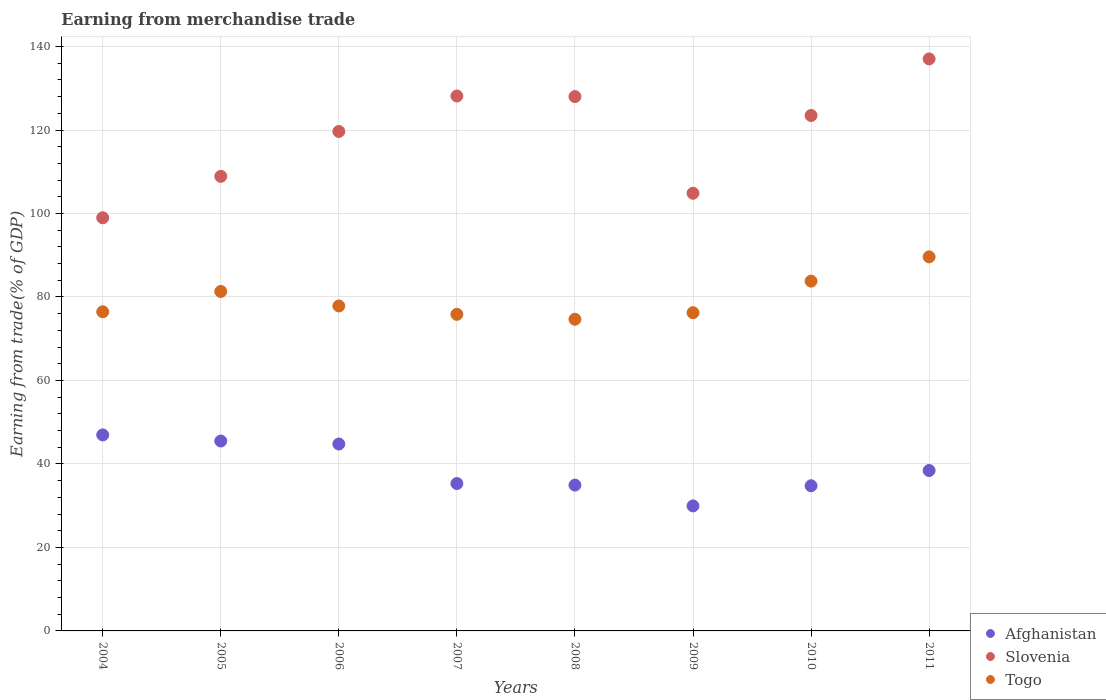What is the earnings from trade in Togo in 2008?
Keep it short and to the point. 74.67. Across all years, what is the maximum earnings from trade in Togo?
Your answer should be very brief. 89.62. Across all years, what is the minimum earnings from trade in Togo?
Make the answer very short. 74.67. What is the total earnings from trade in Slovenia in the graph?
Ensure brevity in your answer.  949.1. What is the difference between the earnings from trade in Slovenia in 2008 and that in 2010?
Offer a very short reply. 4.53. What is the difference between the earnings from trade in Togo in 2008 and the earnings from trade in Afghanistan in 2010?
Offer a very short reply. 39.89. What is the average earnings from trade in Togo per year?
Ensure brevity in your answer.  79.48. In the year 2009, what is the difference between the earnings from trade in Togo and earnings from trade in Afghanistan?
Offer a terse response. 46.29. What is the ratio of the earnings from trade in Togo in 2004 to that in 2006?
Offer a very short reply. 0.98. Is the earnings from trade in Togo in 2007 less than that in 2008?
Make the answer very short. No. Is the difference between the earnings from trade in Togo in 2004 and 2006 greater than the difference between the earnings from trade in Afghanistan in 2004 and 2006?
Offer a terse response. No. What is the difference between the highest and the second highest earnings from trade in Togo?
Give a very brief answer. 5.82. What is the difference between the highest and the lowest earnings from trade in Slovenia?
Keep it short and to the point. 38.05. In how many years, is the earnings from trade in Afghanistan greater than the average earnings from trade in Afghanistan taken over all years?
Ensure brevity in your answer.  3. Is it the case that in every year, the sum of the earnings from trade in Slovenia and earnings from trade in Afghanistan  is greater than the earnings from trade in Togo?
Offer a very short reply. Yes. Is the earnings from trade in Togo strictly less than the earnings from trade in Slovenia over the years?
Keep it short and to the point. Yes. How many years are there in the graph?
Provide a short and direct response. 8. Are the values on the major ticks of Y-axis written in scientific E-notation?
Keep it short and to the point. No. Does the graph contain grids?
Your answer should be very brief. Yes. How are the legend labels stacked?
Your answer should be very brief. Vertical. What is the title of the graph?
Ensure brevity in your answer.  Earning from merchandise trade. Does "Guam" appear as one of the legend labels in the graph?
Give a very brief answer. No. What is the label or title of the X-axis?
Make the answer very short. Years. What is the label or title of the Y-axis?
Provide a short and direct response. Earning from trade(% of GDP). What is the Earning from trade(% of GDP) of Afghanistan in 2004?
Offer a terse response. 46.96. What is the Earning from trade(% of GDP) of Slovenia in 2004?
Ensure brevity in your answer.  98.98. What is the Earning from trade(% of GDP) in Togo in 2004?
Provide a short and direct response. 76.46. What is the Earning from trade(% of GDP) of Afghanistan in 2005?
Your answer should be very brief. 45.49. What is the Earning from trade(% of GDP) of Slovenia in 2005?
Your answer should be compact. 108.91. What is the Earning from trade(% of GDP) in Togo in 2005?
Provide a succinct answer. 81.33. What is the Earning from trade(% of GDP) in Afghanistan in 2006?
Offer a very short reply. 44.78. What is the Earning from trade(% of GDP) in Slovenia in 2006?
Your answer should be compact. 119.66. What is the Earning from trade(% of GDP) in Togo in 2006?
Make the answer very short. 77.85. What is the Earning from trade(% of GDP) in Afghanistan in 2007?
Give a very brief answer. 35.31. What is the Earning from trade(% of GDP) of Slovenia in 2007?
Offer a terse response. 128.15. What is the Earning from trade(% of GDP) in Togo in 2007?
Ensure brevity in your answer.  75.85. What is the Earning from trade(% of GDP) of Afghanistan in 2008?
Your response must be concise. 34.93. What is the Earning from trade(% of GDP) of Slovenia in 2008?
Provide a succinct answer. 128.01. What is the Earning from trade(% of GDP) in Togo in 2008?
Offer a terse response. 74.67. What is the Earning from trade(% of GDP) of Afghanistan in 2009?
Provide a succinct answer. 29.95. What is the Earning from trade(% of GDP) of Slovenia in 2009?
Your answer should be compact. 104.86. What is the Earning from trade(% of GDP) of Togo in 2009?
Keep it short and to the point. 76.24. What is the Earning from trade(% of GDP) of Afghanistan in 2010?
Provide a succinct answer. 34.78. What is the Earning from trade(% of GDP) in Slovenia in 2010?
Provide a succinct answer. 123.49. What is the Earning from trade(% of GDP) of Togo in 2010?
Keep it short and to the point. 83.8. What is the Earning from trade(% of GDP) of Afghanistan in 2011?
Your response must be concise. 38.43. What is the Earning from trade(% of GDP) of Slovenia in 2011?
Your response must be concise. 137.04. What is the Earning from trade(% of GDP) of Togo in 2011?
Ensure brevity in your answer.  89.62. Across all years, what is the maximum Earning from trade(% of GDP) in Afghanistan?
Offer a very short reply. 46.96. Across all years, what is the maximum Earning from trade(% of GDP) of Slovenia?
Your answer should be compact. 137.04. Across all years, what is the maximum Earning from trade(% of GDP) of Togo?
Your answer should be compact. 89.62. Across all years, what is the minimum Earning from trade(% of GDP) in Afghanistan?
Make the answer very short. 29.95. Across all years, what is the minimum Earning from trade(% of GDP) of Slovenia?
Provide a succinct answer. 98.98. Across all years, what is the minimum Earning from trade(% of GDP) of Togo?
Your answer should be very brief. 74.67. What is the total Earning from trade(% of GDP) in Afghanistan in the graph?
Keep it short and to the point. 310.64. What is the total Earning from trade(% of GDP) in Slovenia in the graph?
Provide a short and direct response. 949.1. What is the total Earning from trade(% of GDP) in Togo in the graph?
Your answer should be compact. 635.82. What is the difference between the Earning from trade(% of GDP) of Afghanistan in 2004 and that in 2005?
Make the answer very short. 1.47. What is the difference between the Earning from trade(% of GDP) in Slovenia in 2004 and that in 2005?
Your answer should be compact. -9.92. What is the difference between the Earning from trade(% of GDP) of Togo in 2004 and that in 2005?
Provide a short and direct response. -4.88. What is the difference between the Earning from trade(% of GDP) in Afghanistan in 2004 and that in 2006?
Keep it short and to the point. 2.18. What is the difference between the Earning from trade(% of GDP) of Slovenia in 2004 and that in 2006?
Ensure brevity in your answer.  -20.68. What is the difference between the Earning from trade(% of GDP) of Togo in 2004 and that in 2006?
Keep it short and to the point. -1.4. What is the difference between the Earning from trade(% of GDP) of Afghanistan in 2004 and that in 2007?
Offer a very short reply. 11.65. What is the difference between the Earning from trade(% of GDP) in Slovenia in 2004 and that in 2007?
Your response must be concise. -29.17. What is the difference between the Earning from trade(% of GDP) in Togo in 2004 and that in 2007?
Give a very brief answer. 0.61. What is the difference between the Earning from trade(% of GDP) in Afghanistan in 2004 and that in 2008?
Your response must be concise. 12.03. What is the difference between the Earning from trade(% of GDP) of Slovenia in 2004 and that in 2008?
Offer a terse response. -29.03. What is the difference between the Earning from trade(% of GDP) of Togo in 2004 and that in 2008?
Give a very brief answer. 1.79. What is the difference between the Earning from trade(% of GDP) in Afghanistan in 2004 and that in 2009?
Keep it short and to the point. 17.01. What is the difference between the Earning from trade(% of GDP) in Slovenia in 2004 and that in 2009?
Your answer should be very brief. -5.87. What is the difference between the Earning from trade(% of GDP) in Togo in 2004 and that in 2009?
Your answer should be compact. 0.21. What is the difference between the Earning from trade(% of GDP) in Afghanistan in 2004 and that in 2010?
Your answer should be compact. 12.18. What is the difference between the Earning from trade(% of GDP) of Slovenia in 2004 and that in 2010?
Ensure brevity in your answer.  -24.5. What is the difference between the Earning from trade(% of GDP) of Togo in 2004 and that in 2010?
Make the answer very short. -7.34. What is the difference between the Earning from trade(% of GDP) in Afghanistan in 2004 and that in 2011?
Keep it short and to the point. 8.53. What is the difference between the Earning from trade(% of GDP) in Slovenia in 2004 and that in 2011?
Your answer should be compact. -38.05. What is the difference between the Earning from trade(% of GDP) of Togo in 2004 and that in 2011?
Offer a terse response. -13.16. What is the difference between the Earning from trade(% of GDP) of Afghanistan in 2005 and that in 2006?
Provide a short and direct response. 0.72. What is the difference between the Earning from trade(% of GDP) in Slovenia in 2005 and that in 2006?
Provide a succinct answer. -10.75. What is the difference between the Earning from trade(% of GDP) of Togo in 2005 and that in 2006?
Make the answer very short. 3.48. What is the difference between the Earning from trade(% of GDP) in Afghanistan in 2005 and that in 2007?
Give a very brief answer. 10.18. What is the difference between the Earning from trade(% of GDP) of Slovenia in 2005 and that in 2007?
Provide a succinct answer. -19.25. What is the difference between the Earning from trade(% of GDP) in Togo in 2005 and that in 2007?
Make the answer very short. 5.49. What is the difference between the Earning from trade(% of GDP) of Afghanistan in 2005 and that in 2008?
Your answer should be compact. 10.56. What is the difference between the Earning from trade(% of GDP) of Slovenia in 2005 and that in 2008?
Offer a very short reply. -19.11. What is the difference between the Earning from trade(% of GDP) in Togo in 2005 and that in 2008?
Your answer should be very brief. 6.67. What is the difference between the Earning from trade(% of GDP) in Afghanistan in 2005 and that in 2009?
Your answer should be very brief. 15.54. What is the difference between the Earning from trade(% of GDP) in Slovenia in 2005 and that in 2009?
Offer a very short reply. 4.05. What is the difference between the Earning from trade(% of GDP) of Togo in 2005 and that in 2009?
Offer a terse response. 5.09. What is the difference between the Earning from trade(% of GDP) of Afghanistan in 2005 and that in 2010?
Your answer should be compact. 10.71. What is the difference between the Earning from trade(% of GDP) in Slovenia in 2005 and that in 2010?
Give a very brief answer. -14.58. What is the difference between the Earning from trade(% of GDP) of Togo in 2005 and that in 2010?
Ensure brevity in your answer.  -2.47. What is the difference between the Earning from trade(% of GDP) in Afghanistan in 2005 and that in 2011?
Make the answer very short. 7.06. What is the difference between the Earning from trade(% of GDP) of Slovenia in 2005 and that in 2011?
Offer a very short reply. -28.13. What is the difference between the Earning from trade(% of GDP) of Togo in 2005 and that in 2011?
Ensure brevity in your answer.  -8.28. What is the difference between the Earning from trade(% of GDP) in Afghanistan in 2006 and that in 2007?
Make the answer very short. 9.47. What is the difference between the Earning from trade(% of GDP) of Slovenia in 2006 and that in 2007?
Your answer should be compact. -8.49. What is the difference between the Earning from trade(% of GDP) in Togo in 2006 and that in 2007?
Offer a terse response. 2.01. What is the difference between the Earning from trade(% of GDP) of Afghanistan in 2006 and that in 2008?
Your answer should be very brief. 9.84. What is the difference between the Earning from trade(% of GDP) of Slovenia in 2006 and that in 2008?
Offer a terse response. -8.35. What is the difference between the Earning from trade(% of GDP) of Togo in 2006 and that in 2008?
Ensure brevity in your answer.  3.19. What is the difference between the Earning from trade(% of GDP) in Afghanistan in 2006 and that in 2009?
Keep it short and to the point. 14.83. What is the difference between the Earning from trade(% of GDP) of Slovenia in 2006 and that in 2009?
Offer a terse response. 14.81. What is the difference between the Earning from trade(% of GDP) in Togo in 2006 and that in 2009?
Your answer should be very brief. 1.61. What is the difference between the Earning from trade(% of GDP) of Afghanistan in 2006 and that in 2010?
Your answer should be compact. 10. What is the difference between the Earning from trade(% of GDP) of Slovenia in 2006 and that in 2010?
Ensure brevity in your answer.  -3.83. What is the difference between the Earning from trade(% of GDP) of Togo in 2006 and that in 2010?
Offer a terse response. -5.94. What is the difference between the Earning from trade(% of GDP) in Afghanistan in 2006 and that in 2011?
Offer a terse response. 6.35. What is the difference between the Earning from trade(% of GDP) of Slovenia in 2006 and that in 2011?
Your answer should be very brief. -17.38. What is the difference between the Earning from trade(% of GDP) of Togo in 2006 and that in 2011?
Offer a terse response. -11.76. What is the difference between the Earning from trade(% of GDP) in Afghanistan in 2007 and that in 2008?
Keep it short and to the point. 0.38. What is the difference between the Earning from trade(% of GDP) of Slovenia in 2007 and that in 2008?
Your response must be concise. 0.14. What is the difference between the Earning from trade(% of GDP) of Togo in 2007 and that in 2008?
Your response must be concise. 1.18. What is the difference between the Earning from trade(% of GDP) of Afghanistan in 2007 and that in 2009?
Make the answer very short. 5.36. What is the difference between the Earning from trade(% of GDP) of Slovenia in 2007 and that in 2009?
Keep it short and to the point. 23.3. What is the difference between the Earning from trade(% of GDP) in Togo in 2007 and that in 2009?
Offer a terse response. -0.39. What is the difference between the Earning from trade(% of GDP) in Afghanistan in 2007 and that in 2010?
Provide a short and direct response. 0.53. What is the difference between the Earning from trade(% of GDP) in Slovenia in 2007 and that in 2010?
Make the answer very short. 4.67. What is the difference between the Earning from trade(% of GDP) of Togo in 2007 and that in 2010?
Keep it short and to the point. -7.95. What is the difference between the Earning from trade(% of GDP) in Afghanistan in 2007 and that in 2011?
Your answer should be very brief. -3.12. What is the difference between the Earning from trade(% of GDP) of Slovenia in 2007 and that in 2011?
Your answer should be very brief. -8.88. What is the difference between the Earning from trade(% of GDP) of Togo in 2007 and that in 2011?
Ensure brevity in your answer.  -13.77. What is the difference between the Earning from trade(% of GDP) of Afghanistan in 2008 and that in 2009?
Your answer should be very brief. 4.98. What is the difference between the Earning from trade(% of GDP) of Slovenia in 2008 and that in 2009?
Your answer should be compact. 23.16. What is the difference between the Earning from trade(% of GDP) of Togo in 2008 and that in 2009?
Make the answer very short. -1.58. What is the difference between the Earning from trade(% of GDP) of Afghanistan in 2008 and that in 2010?
Provide a short and direct response. 0.15. What is the difference between the Earning from trade(% of GDP) of Slovenia in 2008 and that in 2010?
Give a very brief answer. 4.53. What is the difference between the Earning from trade(% of GDP) in Togo in 2008 and that in 2010?
Offer a very short reply. -9.13. What is the difference between the Earning from trade(% of GDP) of Afghanistan in 2008 and that in 2011?
Make the answer very short. -3.5. What is the difference between the Earning from trade(% of GDP) of Slovenia in 2008 and that in 2011?
Offer a very short reply. -9.02. What is the difference between the Earning from trade(% of GDP) of Togo in 2008 and that in 2011?
Provide a succinct answer. -14.95. What is the difference between the Earning from trade(% of GDP) in Afghanistan in 2009 and that in 2010?
Provide a succinct answer. -4.83. What is the difference between the Earning from trade(% of GDP) of Slovenia in 2009 and that in 2010?
Offer a very short reply. -18.63. What is the difference between the Earning from trade(% of GDP) in Togo in 2009 and that in 2010?
Provide a short and direct response. -7.56. What is the difference between the Earning from trade(% of GDP) in Afghanistan in 2009 and that in 2011?
Give a very brief answer. -8.48. What is the difference between the Earning from trade(% of GDP) in Slovenia in 2009 and that in 2011?
Your response must be concise. -32.18. What is the difference between the Earning from trade(% of GDP) in Togo in 2009 and that in 2011?
Provide a short and direct response. -13.37. What is the difference between the Earning from trade(% of GDP) of Afghanistan in 2010 and that in 2011?
Give a very brief answer. -3.65. What is the difference between the Earning from trade(% of GDP) in Slovenia in 2010 and that in 2011?
Your answer should be compact. -13.55. What is the difference between the Earning from trade(% of GDP) of Togo in 2010 and that in 2011?
Offer a very short reply. -5.82. What is the difference between the Earning from trade(% of GDP) of Afghanistan in 2004 and the Earning from trade(% of GDP) of Slovenia in 2005?
Your answer should be compact. -61.95. What is the difference between the Earning from trade(% of GDP) in Afghanistan in 2004 and the Earning from trade(% of GDP) in Togo in 2005?
Keep it short and to the point. -34.38. What is the difference between the Earning from trade(% of GDP) of Slovenia in 2004 and the Earning from trade(% of GDP) of Togo in 2005?
Offer a terse response. 17.65. What is the difference between the Earning from trade(% of GDP) of Afghanistan in 2004 and the Earning from trade(% of GDP) of Slovenia in 2006?
Your response must be concise. -72.7. What is the difference between the Earning from trade(% of GDP) of Afghanistan in 2004 and the Earning from trade(% of GDP) of Togo in 2006?
Your answer should be compact. -30.9. What is the difference between the Earning from trade(% of GDP) in Slovenia in 2004 and the Earning from trade(% of GDP) in Togo in 2006?
Your answer should be very brief. 21.13. What is the difference between the Earning from trade(% of GDP) of Afghanistan in 2004 and the Earning from trade(% of GDP) of Slovenia in 2007?
Give a very brief answer. -81.19. What is the difference between the Earning from trade(% of GDP) of Afghanistan in 2004 and the Earning from trade(% of GDP) of Togo in 2007?
Your response must be concise. -28.89. What is the difference between the Earning from trade(% of GDP) of Slovenia in 2004 and the Earning from trade(% of GDP) of Togo in 2007?
Offer a terse response. 23.14. What is the difference between the Earning from trade(% of GDP) in Afghanistan in 2004 and the Earning from trade(% of GDP) in Slovenia in 2008?
Provide a short and direct response. -81.05. What is the difference between the Earning from trade(% of GDP) in Afghanistan in 2004 and the Earning from trade(% of GDP) in Togo in 2008?
Your response must be concise. -27.71. What is the difference between the Earning from trade(% of GDP) of Slovenia in 2004 and the Earning from trade(% of GDP) of Togo in 2008?
Provide a succinct answer. 24.32. What is the difference between the Earning from trade(% of GDP) in Afghanistan in 2004 and the Earning from trade(% of GDP) in Slovenia in 2009?
Offer a terse response. -57.9. What is the difference between the Earning from trade(% of GDP) in Afghanistan in 2004 and the Earning from trade(% of GDP) in Togo in 2009?
Provide a short and direct response. -29.28. What is the difference between the Earning from trade(% of GDP) in Slovenia in 2004 and the Earning from trade(% of GDP) in Togo in 2009?
Provide a succinct answer. 22.74. What is the difference between the Earning from trade(% of GDP) in Afghanistan in 2004 and the Earning from trade(% of GDP) in Slovenia in 2010?
Give a very brief answer. -76.53. What is the difference between the Earning from trade(% of GDP) of Afghanistan in 2004 and the Earning from trade(% of GDP) of Togo in 2010?
Give a very brief answer. -36.84. What is the difference between the Earning from trade(% of GDP) of Slovenia in 2004 and the Earning from trade(% of GDP) of Togo in 2010?
Give a very brief answer. 15.18. What is the difference between the Earning from trade(% of GDP) of Afghanistan in 2004 and the Earning from trade(% of GDP) of Slovenia in 2011?
Offer a terse response. -90.08. What is the difference between the Earning from trade(% of GDP) of Afghanistan in 2004 and the Earning from trade(% of GDP) of Togo in 2011?
Your answer should be compact. -42.66. What is the difference between the Earning from trade(% of GDP) of Slovenia in 2004 and the Earning from trade(% of GDP) of Togo in 2011?
Make the answer very short. 9.37. What is the difference between the Earning from trade(% of GDP) in Afghanistan in 2005 and the Earning from trade(% of GDP) in Slovenia in 2006?
Your answer should be compact. -74.17. What is the difference between the Earning from trade(% of GDP) of Afghanistan in 2005 and the Earning from trade(% of GDP) of Togo in 2006?
Make the answer very short. -32.36. What is the difference between the Earning from trade(% of GDP) in Slovenia in 2005 and the Earning from trade(% of GDP) in Togo in 2006?
Offer a terse response. 31.05. What is the difference between the Earning from trade(% of GDP) in Afghanistan in 2005 and the Earning from trade(% of GDP) in Slovenia in 2007?
Your answer should be very brief. -82.66. What is the difference between the Earning from trade(% of GDP) in Afghanistan in 2005 and the Earning from trade(% of GDP) in Togo in 2007?
Provide a succinct answer. -30.36. What is the difference between the Earning from trade(% of GDP) of Slovenia in 2005 and the Earning from trade(% of GDP) of Togo in 2007?
Make the answer very short. 33.06. What is the difference between the Earning from trade(% of GDP) in Afghanistan in 2005 and the Earning from trade(% of GDP) in Slovenia in 2008?
Your response must be concise. -82.52. What is the difference between the Earning from trade(% of GDP) in Afghanistan in 2005 and the Earning from trade(% of GDP) in Togo in 2008?
Provide a succinct answer. -29.17. What is the difference between the Earning from trade(% of GDP) of Slovenia in 2005 and the Earning from trade(% of GDP) of Togo in 2008?
Offer a terse response. 34.24. What is the difference between the Earning from trade(% of GDP) of Afghanistan in 2005 and the Earning from trade(% of GDP) of Slovenia in 2009?
Provide a short and direct response. -59.36. What is the difference between the Earning from trade(% of GDP) of Afghanistan in 2005 and the Earning from trade(% of GDP) of Togo in 2009?
Your answer should be compact. -30.75. What is the difference between the Earning from trade(% of GDP) in Slovenia in 2005 and the Earning from trade(% of GDP) in Togo in 2009?
Your response must be concise. 32.66. What is the difference between the Earning from trade(% of GDP) of Afghanistan in 2005 and the Earning from trade(% of GDP) of Slovenia in 2010?
Provide a succinct answer. -77.99. What is the difference between the Earning from trade(% of GDP) in Afghanistan in 2005 and the Earning from trade(% of GDP) in Togo in 2010?
Your response must be concise. -38.31. What is the difference between the Earning from trade(% of GDP) in Slovenia in 2005 and the Earning from trade(% of GDP) in Togo in 2010?
Make the answer very short. 25.11. What is the difference between the Earning from trade(% of GDP) of Afghanistan in 2005 and the Earning from trade(% of GDP) of Slovenia in 2011?
Your answer should be very brief. -91.54. What is the difference between the Earning from trade(% of GDP) of Afghanistan in 2005 and the Earning from trade(% of GDP) of Togo in 2011?
Your response must be concise. -44.12. What is the difference between the Earning from trade(% of GDP) of Slovenia in 2005 and the Earning from trade(% of GDP) of Togo in 2011?
Offer a very short reply. 19.29. What is the difference between the Earning from trade(% of GDP) in Afghanistan in 2006 and the Earning from trade(% of GDP) in Slovenia in 2007?
Keep it short and to the point. -83.38. What is the difference between the Earning from trade(% of GDP) in Afghanistan in 2006 and the Earning from trade(% of GDP) in Togo in 2007?
Keep it short and to the point. -31.07. What is the difference between the Earning from trade(% of GDP) in Slovenia in 2006 and the Earning from trade(% of GDP) in Togo in 2007?
Ensure brevity in your answer.  43.81. What is the difference between the Earning from trade(% of GDP) of Afghanistan in 2006 and the Earning from trade(% of GDP) of Slovenia in 2008?
Your answer should be very brief. -83.24. What is the difference between the Earning from trade(% of GDP) of Afghanistan in 2006 and the Earning from trade(% of GDP) of Togo in 2008?
Offer a terse response. -29.89. What is the difference between the Earning from trade(% of GDP) in Slovenia in 2006 and the Earning from trade(% of GDP) in Togo in 2008?
Make the answer very short. 44.99. What is the difference between the Earning from trade(% of GDP) of Afghanistan in 2006 and the Earning from trade(% of GDP) of Slovenia in 2009?
Ensure brevity in your answer.  -60.08. What is the difference between the Earning from trade(% of GDP) of Afghanistan in 2006 and the Earning from trade(% of GDP) of Togo in 2009?
Your response must be concise. -31.47. What is the difference between the Earning from trade(% of GDP) of Slovenia in 2006 and the Earning from trade(% of GDP) of Togo in 2009?
Your answer should be compact. 43.42. What is the difference between the Earning from trade(% of GDP) of Afghanistan in 2006 and the Earning from trade(% of GDP) of Slovenia in 2010?
Your answer should be compact. -78.71. What is the difference between the Earning from trade(% of GDP) of Afghanistan in 2006 and the Earning from trade(% of GDP) of Togo in 2010?
Keep it short and to the point. -39.02. What is the difference between the Earning from trade(% of GDP) in Slovenia in 2006 and the Earning from trade(% of GDP) in Togo in 2010?
Your answer should be compact. 35.86. What is the difference between the Earning from trade(% of GDP) in Afghanistan in 2006 and the Earning from trade(% of GDP) in Slovenia in 2011?
Provide a succinct answer. -92.26. What is the difference between the Earning from trade(% of GDP) of Afghanistan in 2006 and the Earning from trade(% of GDP) of Togo in 2011?
Keep it short and to the point. -44.84. What is the difference between the Earning from trade(% of GDP) of Slovenia in 2006 and the Earning from trade(% of GDP) of Togo in 2011?
Keep it short and to the point. 30.04. What is the difference between the Earning from trade(% of GDP) of Afghanistan in 2007 and the Earning from trade(% of GDP) of Slovenia in 2008?
Provide a succinct answer. -92.7. What is the difference between the Earning from trade(% of GDP) of Afghanistan in 2007 and the Earning from trade(% of GDP) of Togo in 2008?
Your answer should be very brief. -39.35. What is the difference between the Earning from trade(% of GDP) in Slovenia in 2007 and the Earning from trade(% of GDP) in Togo in 2008?
Your response must be concise. 53.49. What is the difference between the Earning from trade(% of GDP) in Afghanistan in 2007 and the Earning from trade(% of GDP) in Slovenia in 2009?
Your response must be concise. -69.54. What is the difference between the Earning from trade(% of GDP) in Afghanistan in 2007 and the Earning from trade(% of GDP) in Togo in 2009?
Your answer should be compact. -40.93. What is the difference between the Earning from trade(% of GDP) of Slovenia in 2007 and the Earning from trade(% of GDP) of Togo in 2009?
Ensure brevity in your answer.  51.91. What is the difference between the Earning from trade(% of GDP) in Afghanistan in 2007 and the Earning from trade(% of GDP) in Slovenia in 2010?
Your response must be concise. -88.17. What is the difference between the Earning from trade(% of GDP) of Afghanistan in 2007 and the Earning from trade(% of GDP) of Togo in 2010?
Give a very brief answer. -48.49. What is the difference between the Earning from trade(% of GDP) in Slovenia in 2007 and the Earning from trade(% of GDP) in Togo in 2010?
Ensure brevity in your answer.  44.35. What is the difference between the Earning from trade(% of GDP) in Afghanistan in 2007 and the Earning from trade(% of GDP) in Slovenia in 2011?
Your answer should be very brief. -101.73. What is the difference between the Earning from trade(% of GDP) in Afghanistan in 2007 and the Earning from trade(% of GDP) in Togo in 2011?
Ensure brevity in your answer.  -54.3. What is the difference between the Earning from trade(% of GDP) of Slovenia in 2007 and the Earning from trade(% of GDP) of Togo in 2011?
Provide a succinct answer. 38.54. What is the difference between the Earning from trade(% of GDP) in Afghanistan in 2008 and the Earning from trade(% of GDP) in Slovenia in 2009?
Your answer should be compact. -69.92. What is the difference between the Earning from trade(% of GDP) in Afghanistan in 2008 and the Earning from trade(% of GDP) in Togo in 2009?
Ensure brevity in your answer.  -41.31. What is the difference between the Earning from trade(% of GDP) of Slovenia in 2008 and the Earning from trade(% of GDP) of Togo in 2009?
Provide a short and direct response. 51.77. What is the difference between the Earning from trade(% of GDP) in Afghanistan in 2008 and the Earning from trade(% of GDP) in Slovenia in 2010?
Make the answer very short. -88.55. What is the difference between the Earning from trade(% of GDP) in Afghanistan in 2008 and the Earning from trade(% of GDP) in Togo in 2010?
Offer a terse response. -48.87. What is the difference between the Earning from trade(% of GDP) in Slovenia in 2008 and the Earning from trade(% of GDP) in Togo in 2010?
Your response must be concise. 44.21. What is the difference between the Earning from trade(% of GDP) of Afghanistan in 2008 and the Earning from trade(% of GDP) of Slovenia in 2011?
Provide a short and direct response. -102.1. What is the difference between the Earning from trade(% of GDP) in Afghanistan in 2008 and the Earning from trade(% of GDP) in Togo in 2011?
Provide a succinct answer. -54.68. What is the difference between the Earning from trade(% of GDP) in Slovenia in 2008 and the Earning from trade(% of GDP) in Togo in 2011?
Your response must be concise. 38.4. What is the difference between the Earning from trade(% of GDP) in Afghanistan in 2009 and the Earning from trade(% of GDP) in Slovenia in 2010?
Provide a short and direct response. -93.54. What is the difference between the Earning from trade(% of GDP) in Afghanistan in 2009 and the Earning from trade(% of GDP) in Togo in 2010?
Your answer should be very brief. -53.85. What is the difference between the Earning from trade(% of GDP) in Slovenia in 2009 and the Earning from trade(% of GDP) in Togo in 2010?
Give a very brief answer. 21.06. What is the difference between the Earning from trade(% of GDP) in Afghanistan in 2009 and the Earning from trade(% of GDP) in Slovenia in 2011?
Your answer should be very brief. -107.09. What is the difference between the Earning from trade(% of GDP) in Afghanistan in 2009 and the Earning from trade(% of GDP) in Togo in 2011?
Your answer should be compact. -59.67. What is the difference between the Earning from trade(% of GDP) in Slovenia in 2009 and the Earning from trade(% of GDP) in Togo in 2011?
Keep it short and to the point. 15.24. What is the difference between the Earning from trade(% of GDP) of Afghanistan in 2010 and the Earning from trade(% of GDP) of Slovenia in 2011?
Offer a terse response. -102.26. What is the difference between the Earning from trade(% of GDP) in Afghanistan in 2010 and the Earning from trade(% of GDP) in Togo in 2011?
Your answer should be very brief. -54.84. What is the difference between the Earning from trade(% of GDP) in Slovenia in 2010 and the Earning from trade(% of GDP) in Togo in 2011?
Provide a succinct answer. 33.87. What is the average Earning from trade(% of GDP) in Afghanistan per year?
Give a very brief answer. 38.83. What is the average Earning from trade(% of GDP) in Slovenia per year?
Ensure brevity in your answer.  118.64. What is the average Earning from trade(% of GDP) in Togo per year?
Provide a short and direct response. 79.48. In the year 2004, what is the difference between the Earning from trade(% of GDP) in Afghanistan and Earning from trade(% of GDP) in Slovenia?
Make the answer very short. -52.02. In the year 2004, what is the difference between the Earning from trade(% of GDP) in Afghanistan and Earning from trade(% of GDP) in Togo?
Your response must be concise. -29.5. In the year 2004, what is the difference between the Earning from trade(% of GDP) of Slovenia and Earning from trade(% of GDP) of Togo?
Make the answer very short. 22.53. In the year 2005, what is the difference between the Earning from trade(% of GDP) in Afghanistan and Earning from trade(% of GDP) in Slovenia?
Provide a succinct answer. -63.41. In the year 2005, what is the difference between the Earning from trade(% of GDP) in Afghanistan and Earning from trade(% of GDP) in Togo?
Offer a terse response. -35.84. In the year 2005, what is the difference between the Earning from trade(% of GDP) in Slovenia and Earning from trade(% of GDP) in Togo?
Provide a short and direct response. 27.57. In the year 2006, what is the difference between the Earning from trade(% of GDP) in Afghanistan and Earning from trade(% of GDP) in Slovenia?
Your response must be concise. -74.88. In the year 2006, what is the difference between the Earning from trade(% of GDP) in Afghanistan and Earning from trade(% of GDP) in Togo?
Offer a very short reply. -33.08. In the year 2006, what is the difference between the Earning from trade(% of GDP) in Slovenia and Earning from trade(% of GDP) in Togo?
Make the answer very short. 41.81. In the year 2007, what is the difference between the Earning from trade(% of GDP) in Afghanistan and Earning from trade(% of GDP) in Slovenia?
Ensure brevity in your answer.  -92.84. In the year 2007, what is the difference between the Earning from trade(% of GDP) in Afghanistan and Earning from trade(% of GDP) in Togo?
Make the answer very short. -40.54. In the year 2007, what is the difference between the Earning from trade(% of GDP) in Slovenia and Earning from trade(% of GDP) in Togo?
Offer a very short reply. 52.31. In the year 2008, what is the difference between the Earning from trade(% of GDP) of Afghanistan and Earning from trade(% of GDP) of Slovenia?
Make the answer very short. -93.08. In the year 2008, what is the difference between the Earning from trade(% of GDP) in Afghanistan and Earning from trade(% of GDP) in Togo?
Provide a succinct answer. -39.73. In the year 2008, what is the difference between the Earning from trade(% of GDP) in Slovenia and Earning from trade(% of GDP) in Togo?
Make the answer very short. 53.35. In the year 2009, what is the difference between the Earning from trade(% of GDP) in Afghanistan and Earning from trade(% of GDP) in Slovenia?
Ensure brevity in your answer.  -74.9. In the year 2009, what is the difference between the Earning from trade(% of GDP) of Afghanistan and Earning from trade(% of GDP) of Togo?
Your response must be concise. -46.29. In the year 2009, what is the difference between the Earning from trade(% of GDP) of Slovenia and Earning from trade(% of GDP) of Togo?
Provide a short and direct response. 28.61. In the year 2010, what is the difference between the Earning from trade(% of GDP) of Afghanistan and Earning from trade(% of GDP) of Slovenia?
Offer a terse response. -88.71. In the year 2010, what is the difference between the Earning from trade(% of GDP) of Afghanistan and Earning from trade(% of GDP) of Togo?
Your answer should be compact. -49.02. In the year 2010, what is the difference between the Earning from trade(% of GDP) of Slovenia and Earning from trade(% of GDP) of Togo?
Keep it short and to the point. 39.69. In the year 2011, what is the difference between the Earning from trade(% of GDP) of Afghanistan and Earning from trade(% of GDP) of Slovenia?
Keep it short and to the point. -98.61. In the year 2011, what is the difference between the Earning from trade(% of GDP) in Afghanistan and Earning from trade(% of GDP) in Togo?
Keep it short and to the point. -51.18. In the year 2011, what is the difference between the Earning from trade(% of GDP) in Slovenia and Earning from trade(% of GDP) in Togo?
Your answer should be compact. 47.42. What is the ratio of the Earning from trade(% of GDP) of Afghanistan in 2004 to that in 2005?
Your answer should be compact. 1.03. What is the ratio of the Earning from trade(% of GDP) of Slovenia in 2004 to that in 2005?
Provide a succinct answer. 0.91. What is the ratio of the Earning from trade(% of GDP) in Afghanistan in 2004 to that in 2006?
Your answer should be compact. 1.05. What is the ratio of the Earning from trade(% of GDP) in Slovenia in 2004 to that in 2006?
Provide a succinct answer. 0.83. What is the ratio of the Earning from trade(% of GDP) in Togo in 2004 to that in 2006?
Keep it short and to the point. 0.98. What is the ratio of the Earning from trade(% of GDP) of Afghanistan in 2004 to that in 2007?
Ensure brevity in your answer.  1.33. What is the ratio of the Earning from trade(% of GDP) in Slovenia in 2004 to that in 2007?
Give a very brief answer. 0.77. What is the ratio of the Earning from trade(% of GDP) in Afghanistan in 2004 to that in 2008?
Your response must be concise. 1.34. What is the ratio of the Earning from trade(% of GDP) in Slovenia in 2004 to that in 2008?
Offer a very short reply. 0.77. What is the ratio of the Earning from trade(% of GDP) in Afghanistan in 2004 to that in 2009?
Your response must be concise. 1.57. What is the ratio of the Earning from trade(% of GDP) of Slovenia in 2004 to that in 2009?
Offer a very short reply. 0.94. What is the ratio of the Earning from trade(% of GDP) in Afghanistan in 2004 to that in 2010?
Provide a succinct answer. 1.35. What is the ratio of the Earning from trade(% of GDP) in Slovenia in 2004 to that in 2010?
Offer a terse response. 0.8. What is the ratio of the Earning from trade(% of GDP) of Togo in 2004 to that in 2010?
Your answer should be very brief. 0.91. What is the ratio of the Earning from trade(% of GDP) in Afghanistan in 2004 to that in 2011?
Offer a very short reply. 1.22. What is the ratio of the Earning from trade(% of GDP) in Slovenia in 2004 to that in 2011?
Keep it short and to the point. 0.72. What is the ratio of the Earning from trade(% of GDP) of Togo in 2004 to that in 2011?
Offer a terse response. 0.85. What is the ratio of the Earning from trade(% of GDP) of Afghanistan in 2005 to that in 2006?
Your answer should be compact. 1.02. What is the ratio of the Earning from trade(% of GDP) in Slovenia in 2005 to that in 2006?
Your answer should be very brief. 0.91. What is the ratio of the Earning from trade(% of GDP) in Togo in 2005 to that in 2006?
Provide a succinct answer. 1.04. What is the ratio of the Earning from trade(% of GDP) of Afghanistan in 2005 to that in 2007?
Offer a terse response. 1.29. What is the ratio of the Earning from trade(% of GDP) in Slovenia in 2005 to that in 2007?
Keep it short and to the point. 0.85. What is the ratio of the Earning from trade(% of GDP) in Togo in 2005 to that in 2007?
Keep it short and to the point. 1.07. What is the ratio of the Earning from trade(% of GDP) in Afghanistan in 2005 to that in 2008?
Your response must be concise. 1.3. What is the ratio of the Earning from trade(% of GDP) of Slovenia in 2005 to that in 2008?
Ensure brevity in your answer.  0.85. What is the ratio of the Earning from trade(% of GDP) in Togo in 2005 to that in 2008?
Give a very brief answer. 1.09. What is the ratio of the Earning from trade(% of GDP) of Afghanistan in 2005 to that in 2009?
Offer a very short reply. 1.52. What is the ratio of the Earning from trade(% of GDP) of Slovenia in 2005 to that in 2009?
Offer a very short reply. 1.04. What is the ratio of the Earning from trade(% of GDP) of Togo in 2005 to that in 2009?
Offer a terse response. 1.07. What is the ratio of the Earning from trade(% of GDP) in Afghanistan in 2005 to that in 2010?
Offer a very short reply. 1.31. What is the ratio of the Earning from trade(% of GDP) of Slovenia in 2005 to that in 2010?
Your answer should be compact. 0.88. What is the ratio of the Earning from trade(% of GDP) in Togo in 2005 to that in 2010?
Your answer should be compact. 0.97. What is the ratio of the Earning from trade(% of GDP) of Afghanistan in 2005 to that in 2011?
Your answer should be compact. 1.18. What is the ratio of the Earning from trade(% of GDP) in Slovenia in 2005 to that in 2011?
Provide a short and direct response. 0.79. What is the ratio of the Earning from trade(% of GDP) of Togo in 2005 to that in 2011?
Your response must be concise. 0.91. What is the ratio of the Earning from trade(% of GDP) in Afghanistan in 2006 to that in 2007?
Provide a succinct answer. 1.27. What is the ratio of the Earning from trade(% of GDP) in Slovenia in 2006 to that in 2007?
Offer a very short reply. 0.93. What is the ratio of the Earning from trade(% of GDP) in Togo in 2006 to that in 2007?
Your answer should be very brief. 1.03. What is the ratio of the Earning from trade(% of GDP) in Afghanistan in 2006 to that in 2008?
Your answer should be compact. 1.28. What is the ratio of the Earning from trade(% of GDP) of Slovenia in 2006 to that in 2008?
Give a very brief answer. 0.93. What is the ratio of the Earning from trade(% of GDP) in Togo in 2006 to that in 2008?
Give a very brief answer. 1.04. What is the ratio of the Earning from trade(% of GDP) in Afghanistan in 2006 to that in 2009?
Give a very brief answer. 1.5. What is the ratio of the Earning from trade(% of GDP) of Slovenia in 2006 to that in 2009?
Your response must be concise. 1.14. What is the ratio of the Earning from trade(% of GDP) of Togo in 2006 to that in 2009?
Provide a succinct answer. 1.02. What is the ratio of the Earning from trade(% of GDP) in Afghanistan in 2006 to that in 2010?
Your answer should be compact. 1.29. What is the ratio of the Earning from trade(% of GDP) of Slovenia in 2006 to that in 2010?
Ensure brevity in your answer.  0.97. What is the ratio of the Earning from trade(% of GDP) in Togo in 2006 to that in 2010?
Provide a short and direct response. 0.93. What is the ratio of the Earning from trade(% of GDP) of Afghanistan in 2006 to that in 2011?
Ensure brevity in your answer.  1.17. What is the ratio of the Earning from trade(% of GDP) of Slovenia in 2006 to that in 2011?
Your response must be concise. 0.87. What is the ratio of the Earning from trade(% of GDP) in Togo in 2006 to that in 2011?
Keep it short and to the point. 0.87. What is the ratio of the Earning from trade(% of GDP) in Afghanistan in 2007 to that in 2008?
Provide a succinct answer. 1.01. What is the ratio of the Earning from trade(% of GDP) of Slovenia in 2007 to that in 2008?
Your response must be concise. 1. What is the ratio of the Earning from trade(% of GDP) of Togo in 2007 to that in 2008?
Your answer should be compact. 1.02. What is the ratio of the Earning from trade(% of GDP) of Afghanistan in 2007 to that in 2009?
Provide a succinct answer. 1.18. What is the ratio of the Earning from trade(% of GDP) of Slovenia in 2007 to that in 2009?
Your response must be concise. 1.22. What is the ratio of the Earning from trade(% of GDP) in Togo in 2007 to that in 2009?
Offer a terse response. 0.99. What is the ratio of the Earning from trade(% of GDP) of Afghanistan in 2007 to that in 2010?
Offer a terse response. 1.02. What is the ratio of the Earning from trade(% of GDP) in Slovenia in 2007 to that in 2010?
Keep it short and to the point. 1.04. What is the ratio of the Earning from trade(% of GDP) in Togo in 2007 to that in 2010?
Keep it short and to the point. 0.91. What is the ratio of the Earning from trade(% of GDP) of Afghanistan in 2007 to that in 2011?
Give a very brief answer. 0.92. What is the ratio of the Earning from trade(% of GDP) of Slovenia in 2007 to that in 2011?
Offer a terse response. 0.94. What is the ratio of the Earning from trade(% of GDP) in Togo in 2007 to that in 2011?
Your response must be concise. 0.85. What is the ratio of the Earning from trade(% of GDP) of Afghanistan in 2008 to that in 2009?
Provide a succinct answer. 1.17. What is the ratio of the Earning from trade(% of GDP) in Slovenia in 2008 to that in 2009?
Offer a very short reply. 1.22. What is the ratio of the Earning from trade(% of GDP) of Togo in 2008 to that in 2009?
Give a very brief answer. 0.98. What is the ratio of the Earning from trade(% of GDP) of Afghanistan in 2008 to that in 2010?
Keep it short and to the point. 1. What is the ratio of the Earning from trade(% of GDP) in Slovenia in 2008 to that in 2010?
Keep it short and to the point. 1.04. What is the ratio of the Earning from trade(% of GDP) of Togo in 2008 to that in 2010?
Provide a succinct answer. 0.89. What is the ratio of the Earning from trade(% of GDP) of Afghanistan in 2008 to that in 2011?
Provide a succinct answer. 0.91. What is the ratio of the Earning from trade(% of GDP) in Slovenia in 2008 to that in 2011?
Your answer should be compact. 0.93. What is the ratio of the Earning from trade(% of GDP) of Togo in 2008 to that in 2011?
Provide a short and direct response. 0.83. What is the ratio of the Earning from trade(% of GDP) in Afghanistan in 2009 to that in 2010?
Your answer should be very brief. 0.86. What is the ratio of the Earning from trade(% of GDP) in Slovenia in 2009 to that in 2010?
Your response must be concise. 0.85. What is the ratio of the Earning from trade(% of GDP) in Togo in 2009 to that in 2010?
Provide a short and direct response. 0.91. What is the ratio of the Earning from trade(% of GDP) in Afghanistan in 2009 to that in 2011?
Offer a very short reply. 0.78. What is the ratio of the Earning from trade(% of GDP) of Slovenia in 2009 to that in 2011?
Ensure brevity in your answer.  0.77. What is the ratio of the Earning from trade(% of GDP) of Togo in 2009 to that in 2011?
Your answer should be very brief. 0.85. What is the ratio of the Earning from trade(% of GDP) in Afghanistan in 2010 to that in 2011?
Offer a terse response. 0.91. What is the ratio of the Earning from trade(% of GDP) of Slovenia in 2010 to that in 2011?
Your answer should be very brief. 0.9. What is the ratio of the Earning from trade(% of GDP) of Togo in 2010 to that in 2011?
Provide a short and direct response. 0.94. What is the difference between the highest and the second highest Earning from trade(% of GDP) of Afghanistan?
Offer a terse response. 1.47. What is the difference between the highest and the second highest Earning from trade(% of GDP) of Slovenia?
Provide a succinct answer. 8.88. What is the difference between the highest and the second highest Earning from trade(% of GDP) in Togo?
Provide a short and direct response. 5.82. What is the difference between the highest and the lowest Earning from trade(% of GDP) of Afghanistan?
Ensure brevity in your answer.  17.01. What is the difference between the highest and the lowest Earning from trade(% of GDP) in Slovenia?
Keep it short and to the point. 38.05. What is the difference between the highest and the lowest Earning from trade(% of GDP) of Togo?
Provide a succinct answer. 14.95. 